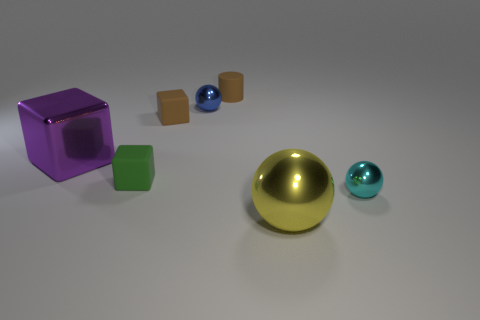How many objects are there in total in the image? There are five objects in total, consisting of two cubes, two spheres, and one hemisphere. 